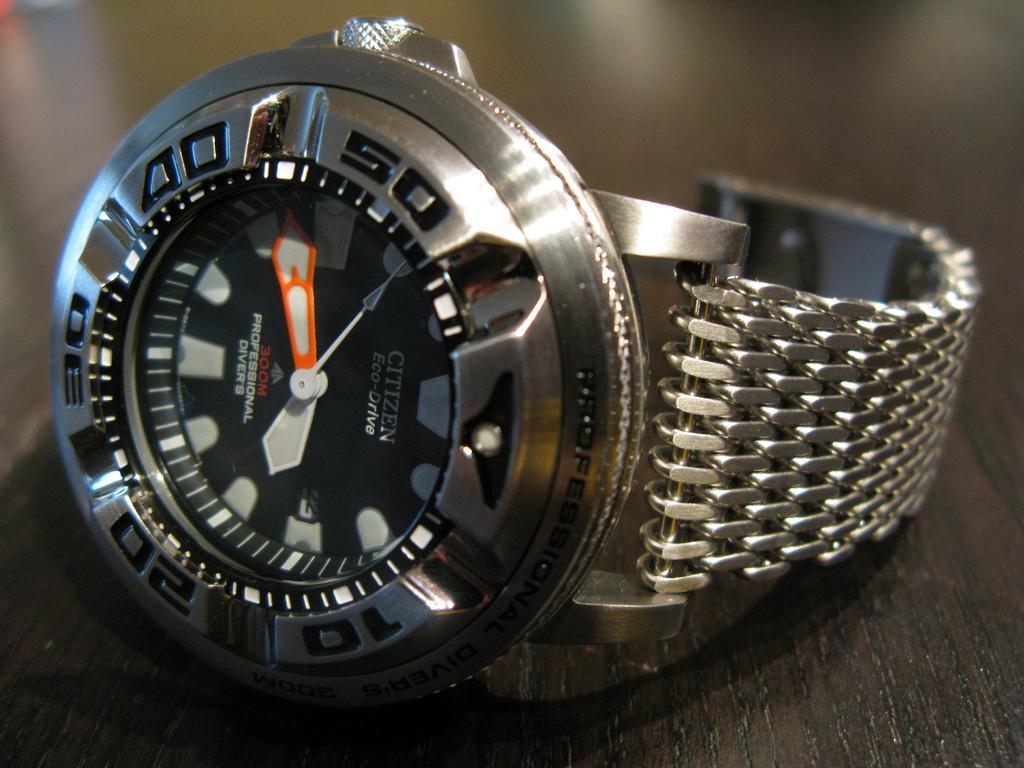Please provide a concise description of this image. In this image we can see a watch on a wooden surface. In the background it is blur. 